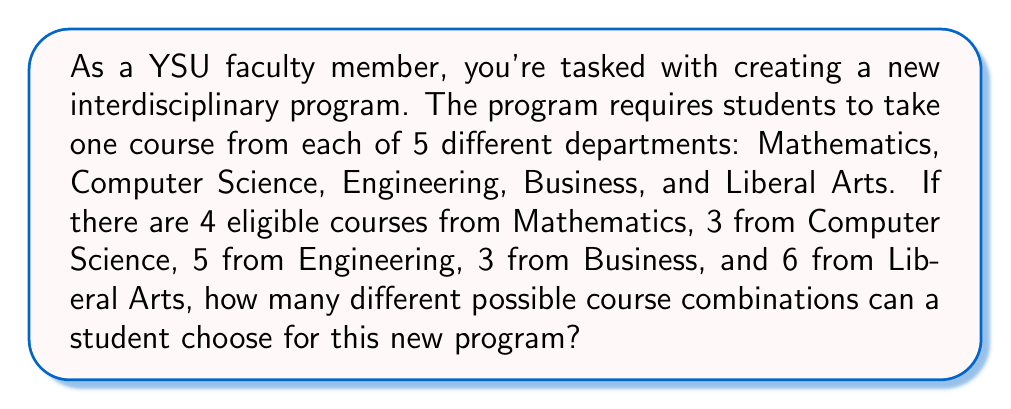Provide a solution to this math problem. To solve this problem, we'll use the multiplication principle of counting. This principle states that if we have a sequence of independent choices, where there are $m_1$ ways of making the first choice, $m_2$ ways of making the second choice, and so on up to $m_n$ ways of making the nth choice, then the total number of ways to make all these choices is the product $m_1 \times m_2 \times ... \times m_n$.

In this case, we have 5 independent choices (one for each department), and the number of options for each choice is as follows:

1. Mathematics: 4 options
2. Computer Science: 3 options
3. Engineering: 5 options
4. Business: 3 options
5. Liberal Arts: 6 options

Therefore, the total number of possible combinations is:

$$ 4 \times 3 \times 5 \times 3 \times 6 $$

Let's calculate this step by step:

$$ 4 \times 3 = 12 $$
$$ 12 \times 5 = 60 $$
$$ 60 \times 3 = 180 $$
$$ 180 \times 6 = 1080 $$

This calculation gives us the total number of possible course combinations for the new interdisciplinary program.
Answer: $1080$ possible course combinations 